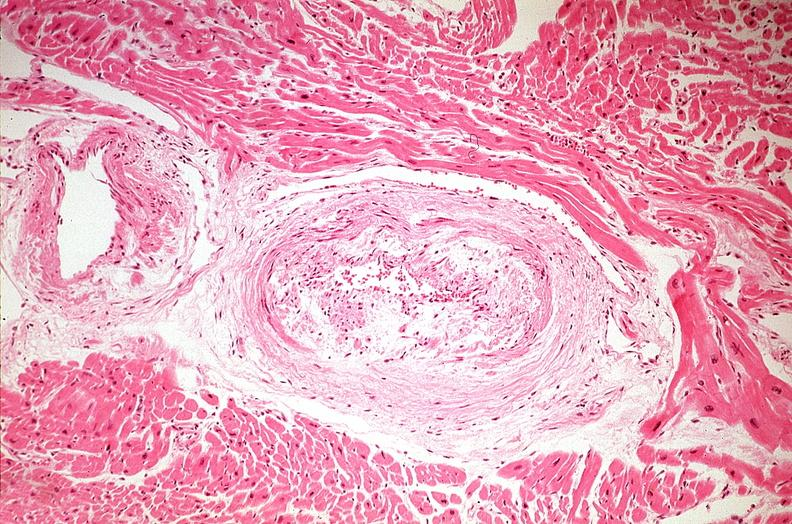what is present?
Answer the question using a single word or phrase. Cardiovascular 